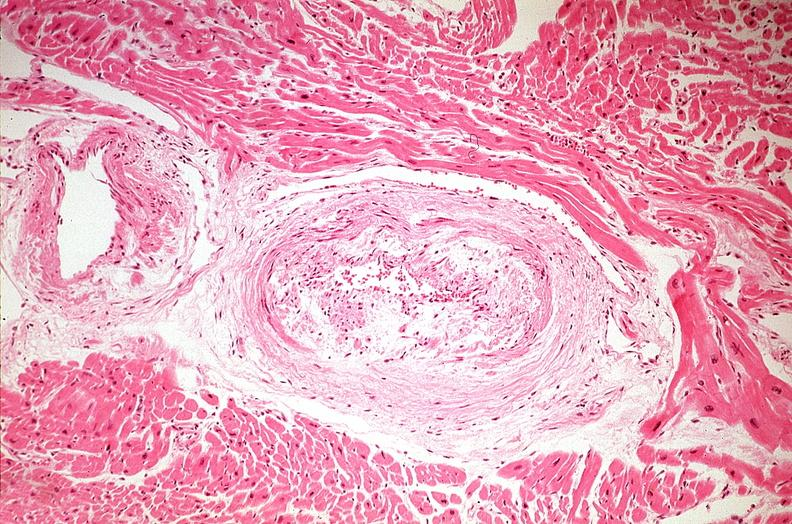what is present?
Answer the question using a single word or phrase. Cardiovascular 